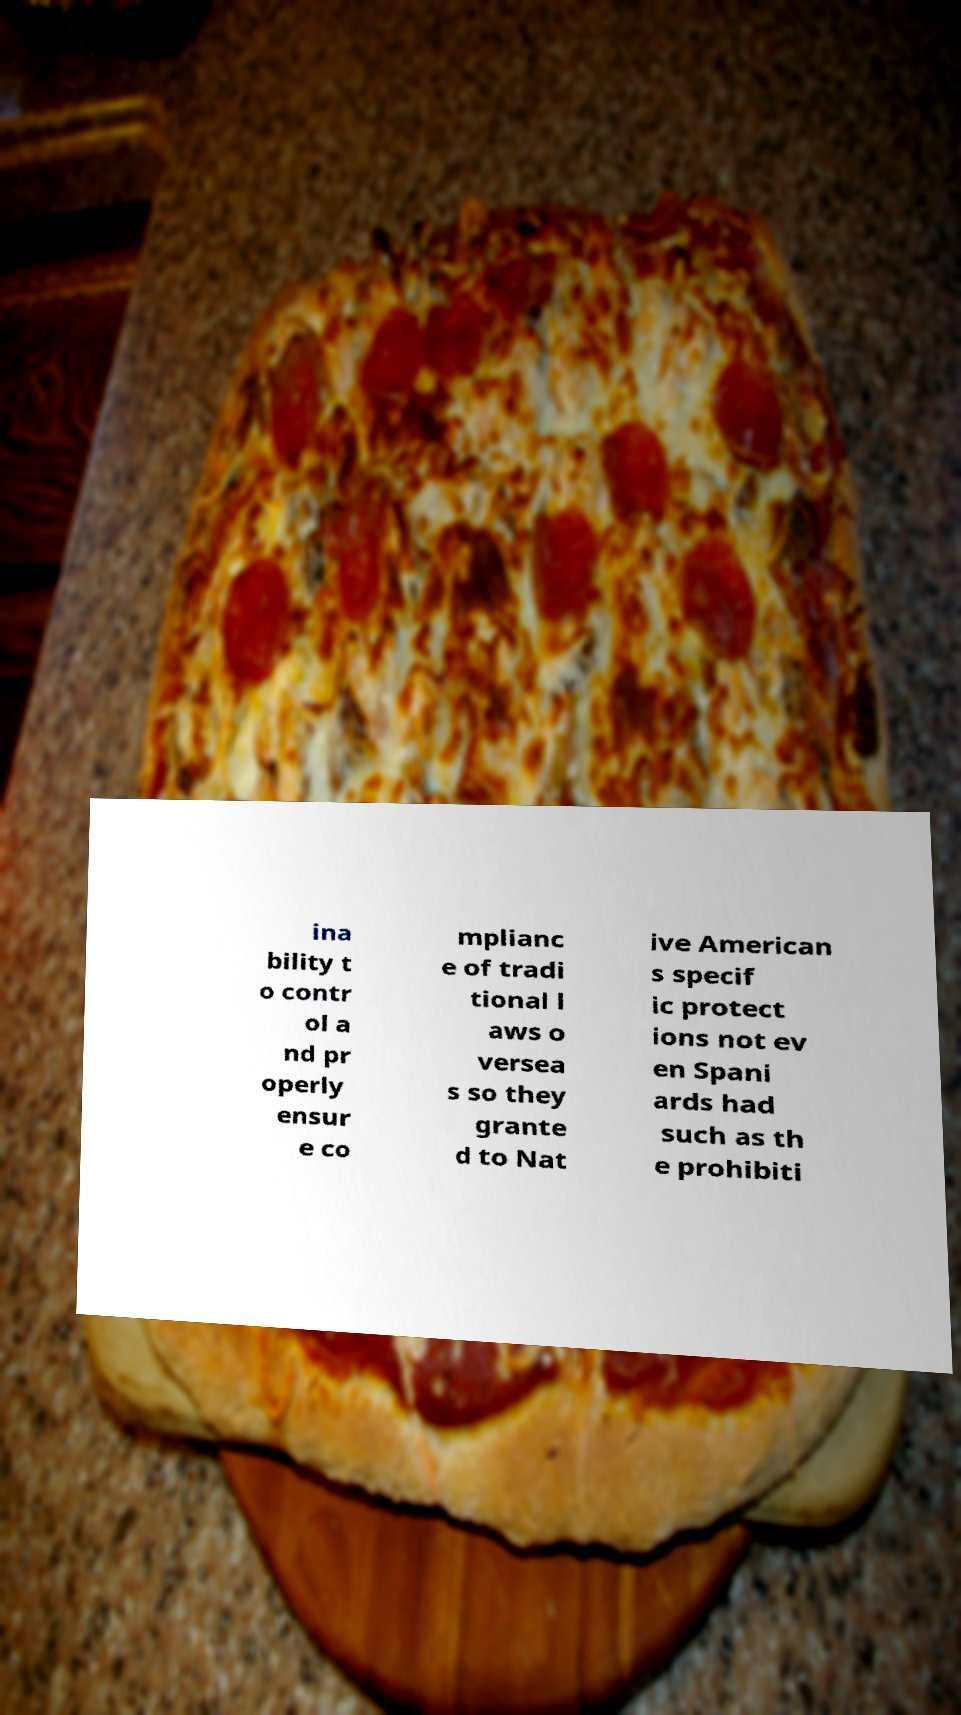Please read and relay the text visible in this image. What does it say? ina bility t o contr ol a nd pr operly ensur e co mplianc e of tradi tional l aws o versea s so they grante d to Nat ive American s specif ic protect ions not ev en Spani ards had such as th e prohibiti 